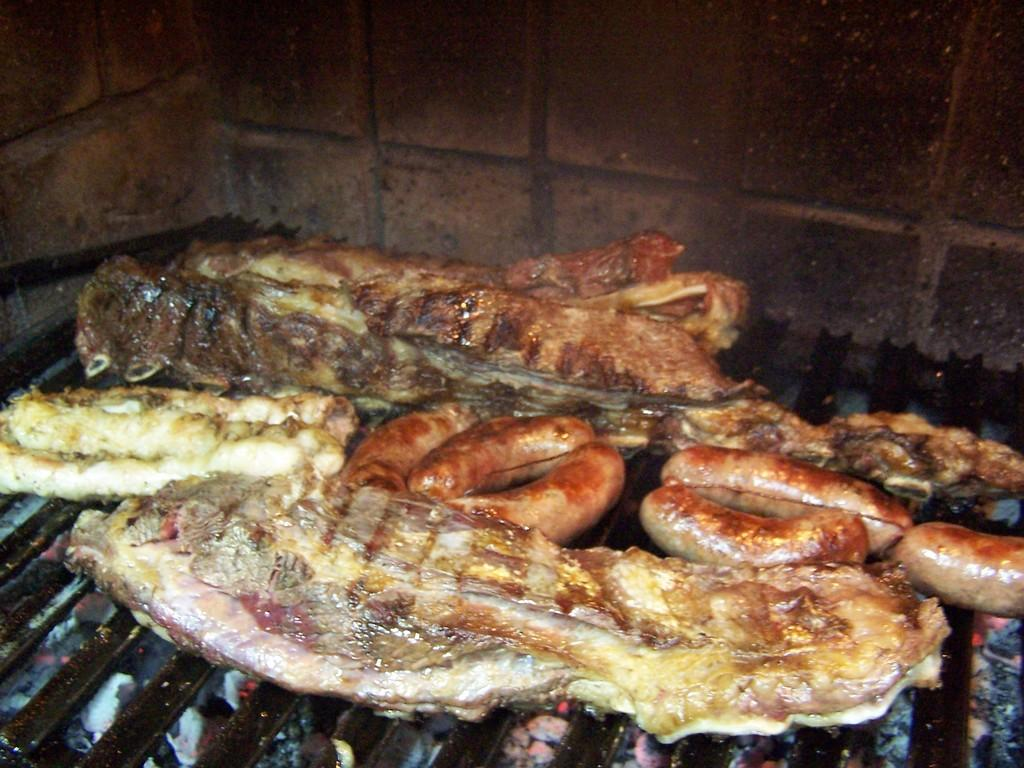What is being cooked in the image? There is food on a grill in the image. What can be seen in the background of the image? There is a wall visible in the background of the image. What type of wool is being used to make the loaf in the image? There is no wool or loaf present in the image; it features food on a grill and a wall in the background. 